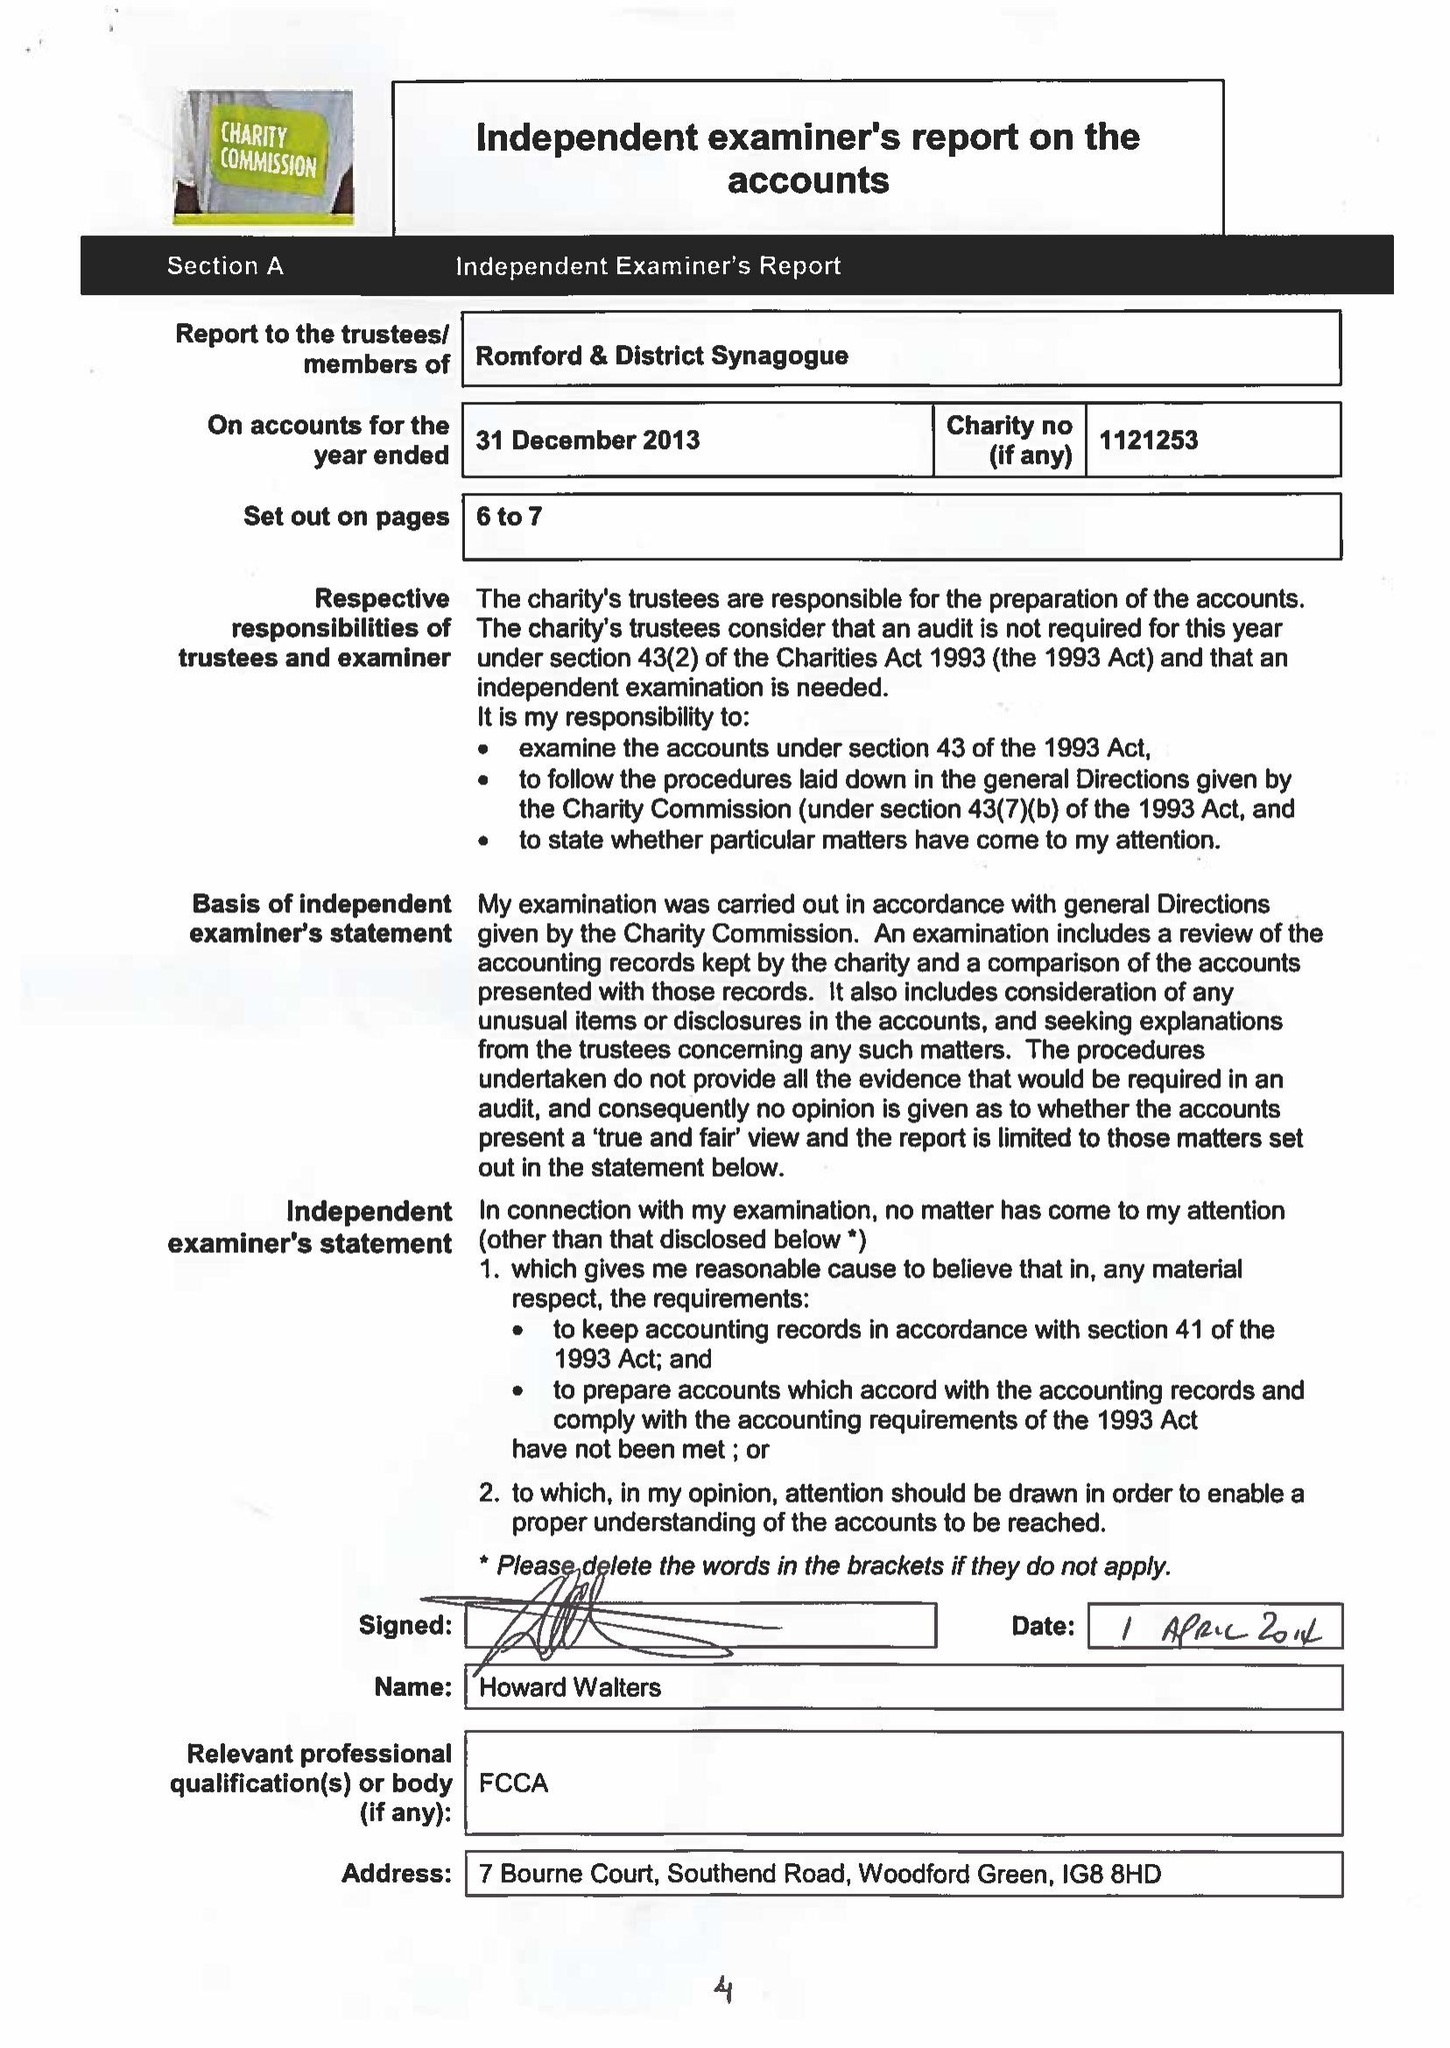What is the value for the charity_name?
Answer the question using a single word or phrase. Romford and District Synagogue 